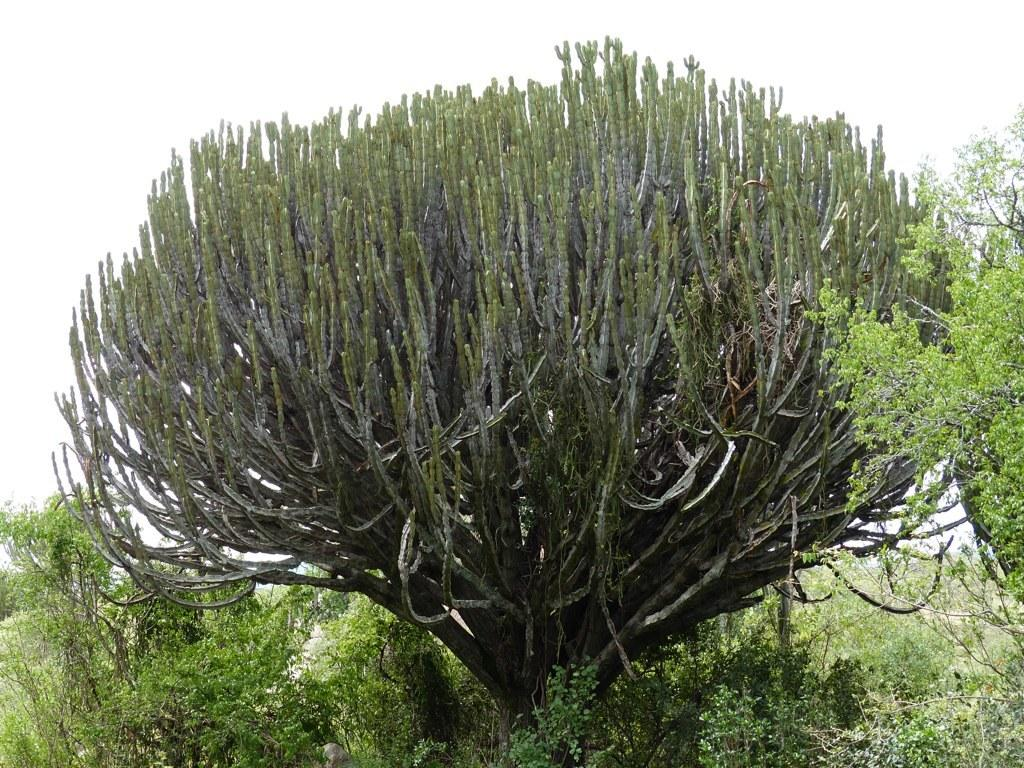What can be seen in the foreground of the image? There is greenery in the foreground of the image. What is visible in the background of the image? The sky is visible in the background of the image. How many rabbits can be seen in the image? There are no rabbits present in the image. What type of pan is being used to cook in the image? There is no pan or cooking activity depicted in the image. 